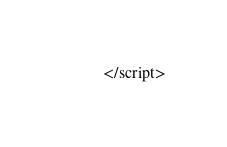<code> <loc_0><loc_0><loc_500><loc_500><_HTML_></script>
</code> 